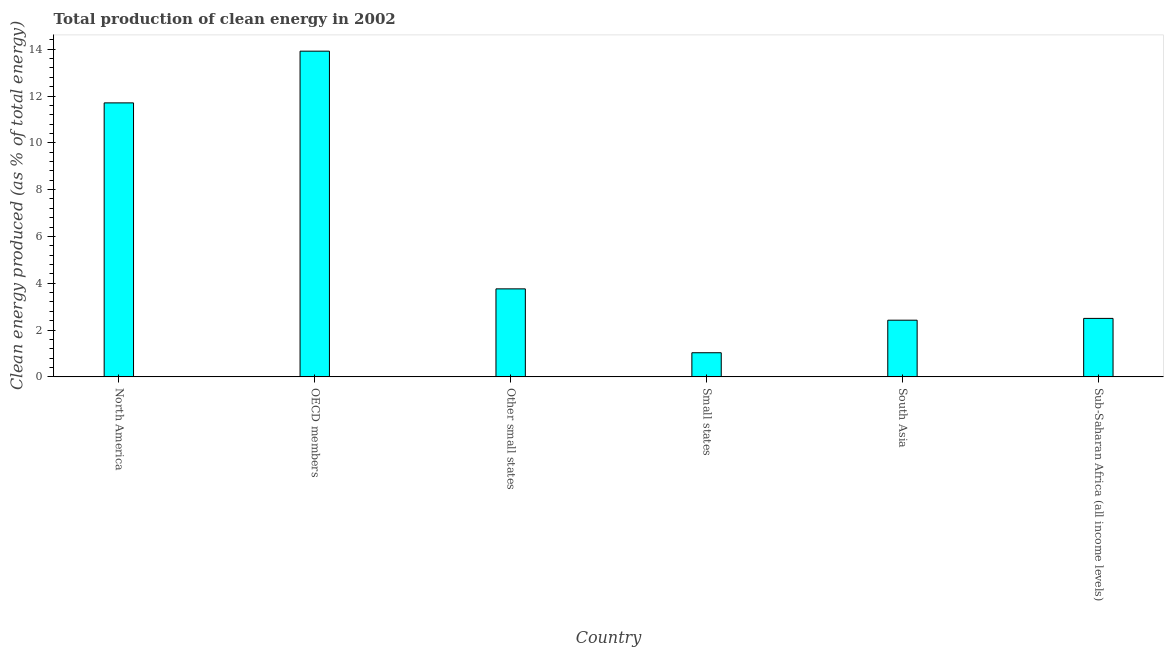Does the graph contain any zero values?
Ensure brevity in your answer.  No. Does the graph contain grids?
Give a very brief answer. No. What is the title of the graph?
Ensure brevity in your answer.  Total production of clean energy in 2002. What is the label or title of the Y-axis?
Your answer should be very brief. Clean energy produced (as % of total energy). What is the production of clean energy in Small states?
Make the answer very short. 1.03. Across all countries, what is the maximum production of clean energy?
Keep it short and to the point. 13.92. Across all countries, what is the minimum production of clean energy?
Provide a succinct answer. 1.03. In which country was the production of clean energy minimum?
Provide a succinct answer. Small states. What is the sum of the production of clean energy?
Your answer should be compact. 35.33. What is the difference between the production of clean energy in Other small states and South Asia?
Provide a short and direct response. 1.34. What is the average production of clean energy per country?
Keep it short and to the point. 5.89. What is the median production of clean energy?
Ensure brevity in your answer.  3.13. In how many countries, is the production of clean energy greater than 10 %?
Provide a short and direct response. 2. What is the ratio of the production of clean energy in Other small states to that in Small states?
Offer a terse response. 3.65. What is the difference between the highest and the second highest production of clean energy?
Ensure brevity in your answer.  2.21. Is the sum of the production of clean energy in OECD members and Other small states greater than the maximum production of clean energy across all countries?
Your response must be concise. Yes. What is the difference between the highest and the lowest production of clean energy?
Offer a very short reply. 12.89. How many bars are there?
Offer a very short reply. 6. Are all the bars in the graph horizontal?
Make the answer very short. No. Are the values on the major ticks of Y-axis written in scientific E-notation?
Your response must be concise. No. What is the Clean energy produced (as % of total energy) of North America?
Give a very brief answer. 11.71. What is the Clean energy produced (as % of total energy) of OECD members?
Your answer should be compact. 13.92. What is the Clean energy produced (as % of total energy) of Other small states?
Provide a succinct answer. 3.76. What is the Clean energy produced (as % of total energy) of Small states?
Offer a very short reply. 1.03. What is the Clean energy produced (as % of total energy) of South Asia?
Keep it short and to the point. 2.42. What is the Clean energy produced (as % of total energy) of Sub-Saharan Africa (all income levels)?
Provide a succinct answer. 2.5. What is the difference between the Clean energy produced (as % of total energy) in North America and OECD members?
Provide a short and direct response. -2.21. What is the difference between the Clean energy produced (as % of total energy) in North America and Other small states?
Provide a succinct answer. 7.95. What is the difference between the Clean energy produced (as % of total energy) in North America and Small states?
Give a very brief answer. 10.68. What is the difference between the Clean energy produced (as % of total energy) in North America and South Asia?
Ensure brevity in your answer.  9.28. What is the difference between the Clean energy produced (as % of total energy) in North America and Sub-Saharan Africa (all income levels)?
Ensure brevity in your answer.  9.21. What is the difference between the Clean energy produced (as % of total energy) in OECD members and Other small states?
Keep it short and to the point. 10.16. What is the difference between the Clean energy produced (as % of total energy) in OECD members and Small states?
Provide a short and direct response. 12.89. What is the difference between the Clean energy produced (as % of total energy) in OECD members and South Asia?
Keep it short and to the point. 11.49. What is the difference between the Clean energy produced (as % of total energy) in OECD members and Sub-Saharan Africa (all income levels)?
Give a very brief answer. 11.42. What is the difference between the Clean energy produced (as % of total energy) in Other small states and Small states?
Your answer should be compact. 2.73. What is the difference between the Clean energy produced (as % of total energy) in Other small states and South Asia?
Your answer should be very brief. 1.34. What is the difference between the Clean energy produced (as % of total energy) in Other small states and Sub-Saharan Africa (all income levels)?
Offer a very short reply. 1.26. What is the difference between the Clean energy produced (as % of total energy) in Small states and South Asia?
Keep it short and to the point. -1.39. What is the difference between the Clean energy produced (as % of total energy) in Small states and Sub-Saharan Africa (all income levels)?
Provide a short and direct response. -1.47. What is the difference between the Clean energy produced (as % of total energy) in South Asia and Sub-Saharan Africa (all income levels)?
Your answer should be compact. -0.08. What is the ratio of the Clean energy produced (as % of total energy) in North America to that in OECD members?
Provide a succinct answer. 0.84. What is the ratio of the Clean energy produced (as % of total energy) in North America to that in Other small states?
Give a very brief answer. 3.11. What is the ratio of the Clean energy produced (as % of total energy) in North America to that in Small states?
Provide a succinct answer. 11.36. What is the ratio of the Clean energy produced (as % of total energy) in North America to that in South Asia?
Offer a terse response. 4.83. What is the ratio of the Clean energy produced (as % of total energy) in North America to that in Sub-Saharan Africa (all income levels)?
Give a very brief answer. 4.69. What is the ratio of the Clean energy produced (as % of total energy) in OECD members to that in Other small states?
Keep it short and to the point. 3.7. What is the ratio of the Clean energy produced (as % of total energy) in OECD members to that in Small states?
Offer a terse response. 13.5. What is the ratio of the Clean energy produced (as % of total energy) in OECD members to that in South Asia?
Your answer should be very brief. 5.75. What is the ratio of the Clean energy produced (as % of total energy) in OECD members to that in Sub-Saharan Africa (all income levels)?
Your answer should be compact. 5.57. What is the ratio of the Clean energy produced (as % of total energy) in Other small states to that in Small states?
Give a very brief answer. 3.65. What is the ratio of the Clean energy produced (as % of total energy) in Other small states to that in South Asia?
Provide a succinct answer. 1.55. What is the ratio of the Clean energy produced (as % of total energy) in Other small states to that in Sub-Saharan Africa (all income levels)?
Your response must be concise. 1.5. What is the ratio of the Clean energy produced (as % of total energy) in Small states to that in South Asia?
Offer a very short reply. 0.43. What is the ratio of the Clean energy produced (as % of total energy) in Small states to that in Sub-Saharan Africa (all income levels)?
Your answer should be compact. 0.41. What is the ratio of the Clean energy produced (as % of total energy) in South Asia to that in Sub-Saharan Africa (all income levels)?
Offer a very short reply. 0.97. 